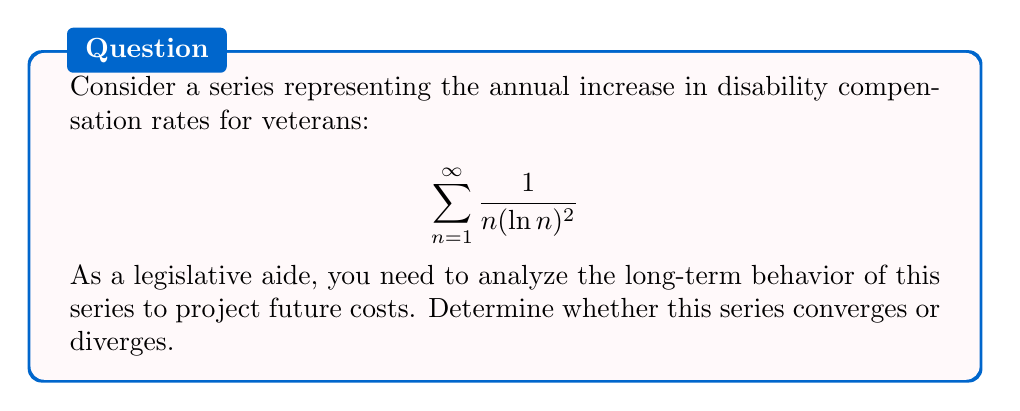What is the answer to this math problem? To analyze the convergence of this series, we'll use the integral test. Let's follow these steps:

1) Define the function $f(x) = \frac{1}{x(\ln x)^2}$ for $x \geq 2$.

2) Check if $f(x)$ is continuous, positive, and decreasing for $x \geq 2$:
   - $f(x)$ is continuous for $x \geq 2$
   - $f(x) > 0$ for $x \geq 2$
   - $f'(x) = -\frac{(\ln x)^2 + 2\ln x}{x^2(\ln x)^4} < 0$ for $x \geq 2$, so $f(x)$ is decreasing

3) Apply the integral test:
   $$\int_2^{\infty} \frac{1}{x(\ln x)^2} dx$$

4) Solve the integral:
   Let $u = \ln x$, then $du = \frac{1}{x}dx$
   $$\int_2^{\infty} \frac{1}{x(\ln x)^2} dx = \int_{\ln 2}^{\infty} \frac{1}{u^2} du = \left[-\frac{1}{u}\right]_{\ln 2}^{\infty} = 0 - \left(-\frac{1}{\ln 2}\right) = \frac{1}{\ln 2}$$

5) Since the integral converges to a finite value, by the integral test, the original series also converges.

This means that the sum of the annual increases in disability compensation rates converges to a finite value, indicating that the long-term costs will not grow unboundedly.
Answer: The series converges. 